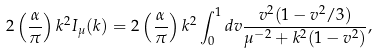Convert formula to latex. <formula><loc_0><loc_0><loc_500><loc_500>2 \left ( \frac { \alpha } { \pi } \right ) k ^ { 2 } I _ { \mu } ( k ) = 2 \left ( \frac { \alpha } { \pi } \right ) k ^ { 2 } \int _ { 0 } ^ { 1 } d v \frac { v ^ { 2 } ( 1 - v ^ { 2 } / 3 ) } { \mu ^ { - 2 } + k ^ { 2 } ( 1 - v ^ { 2 } ) } ,</formula> 